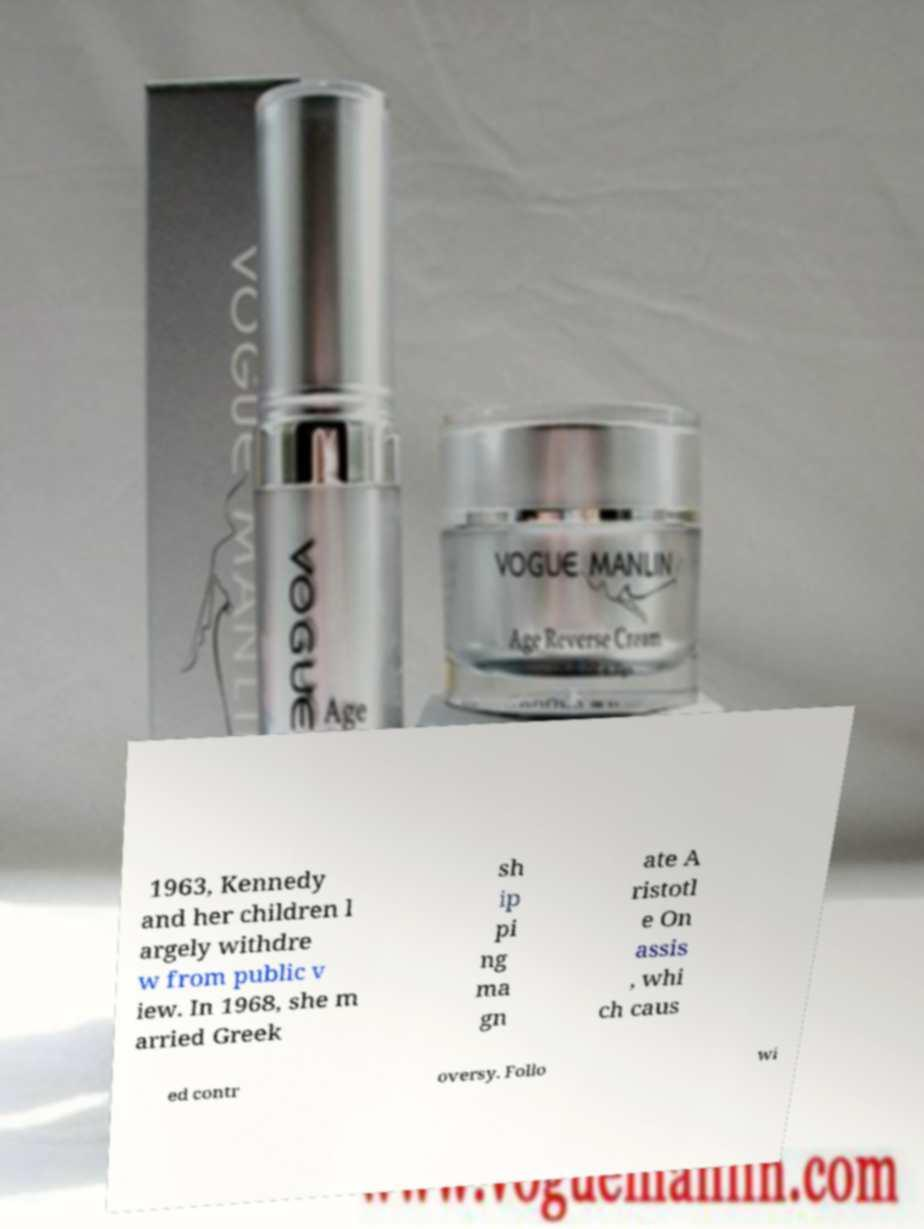For documentation purposes, I need the text within this image transcribed. Could you provide that? 1963, Kennedy and her children l argely withdre w from public v iew. In 1968, she m arried Greek sh ip pi ng ma gn ate A ristotl e On assis , whi ch caus ed contr oversy. Follo wi 